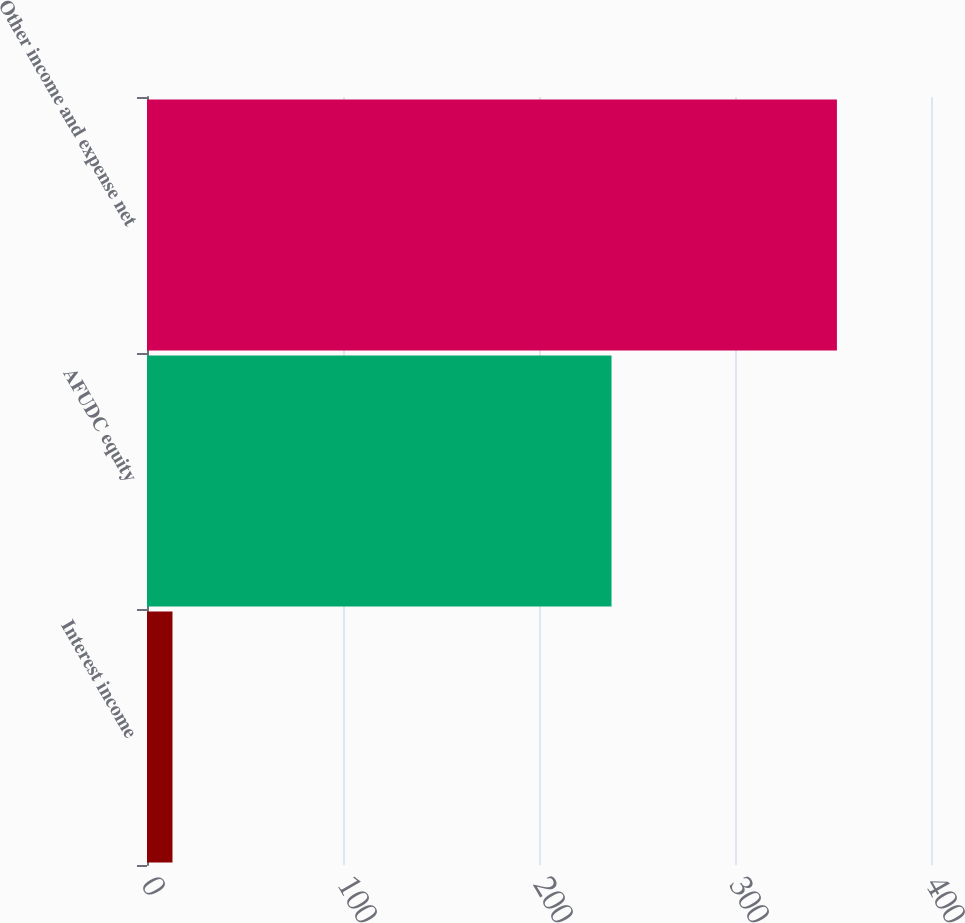Convert chart. <chart><loc_0><loc_0><loc_500><loc_500><bar_chart><fcel>Interest income<fcel>AFUDC equity<fcel>Other income and expense net<nl><fcel>13<fcel>237<fcel>352<nl></chart> 